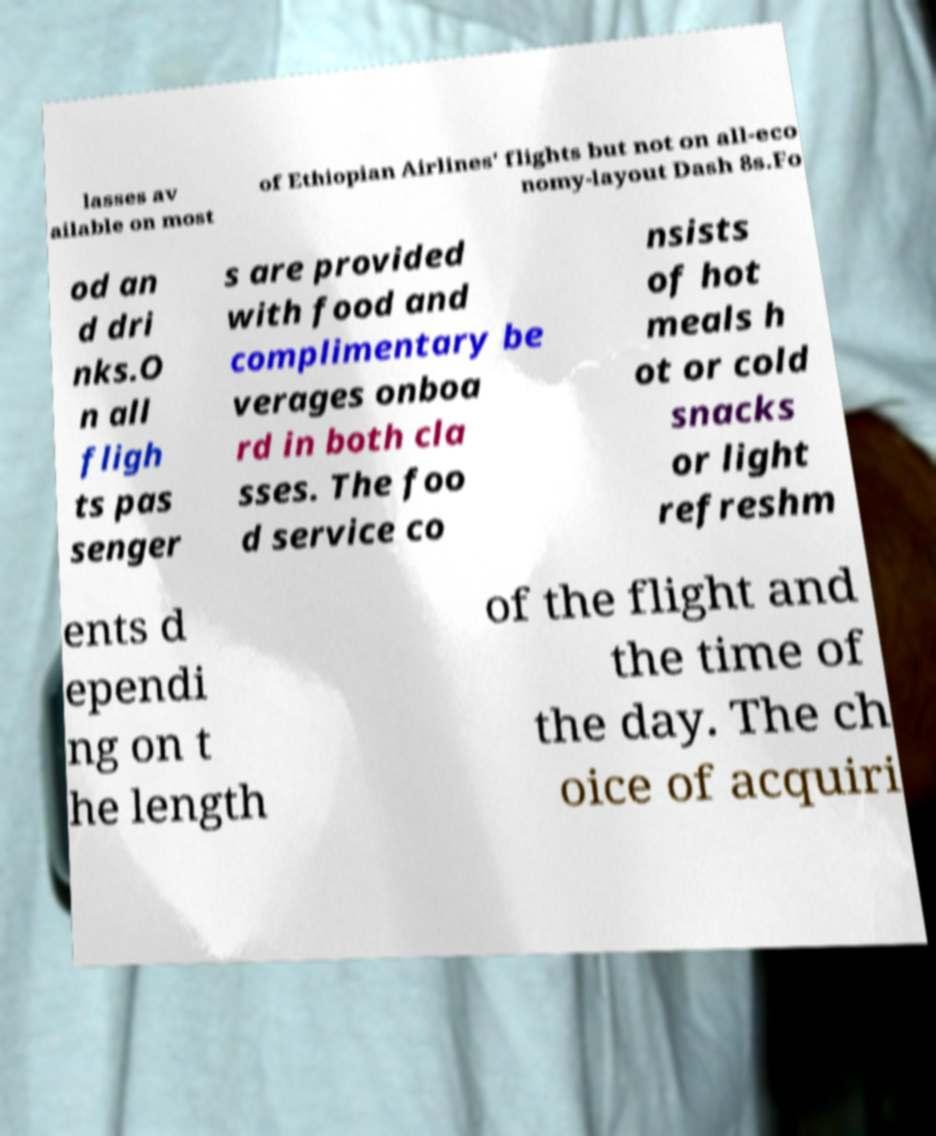Could you extract and type out the text from this image? lasses av ailable on most of Ethiopian Airlines' flights but not on all-eco nomy-layout Dash 8s.Fo od an d dri nks.O n all fligh ts pas senger s are provided with food and complimentary be verages onboa rd in both cla sses. The foo d service co nsists of hot meals h ot or cold snacks or light refreshm ents d ependi ng on t he length of the flight and the time of the day. The ch oice of acquiri 